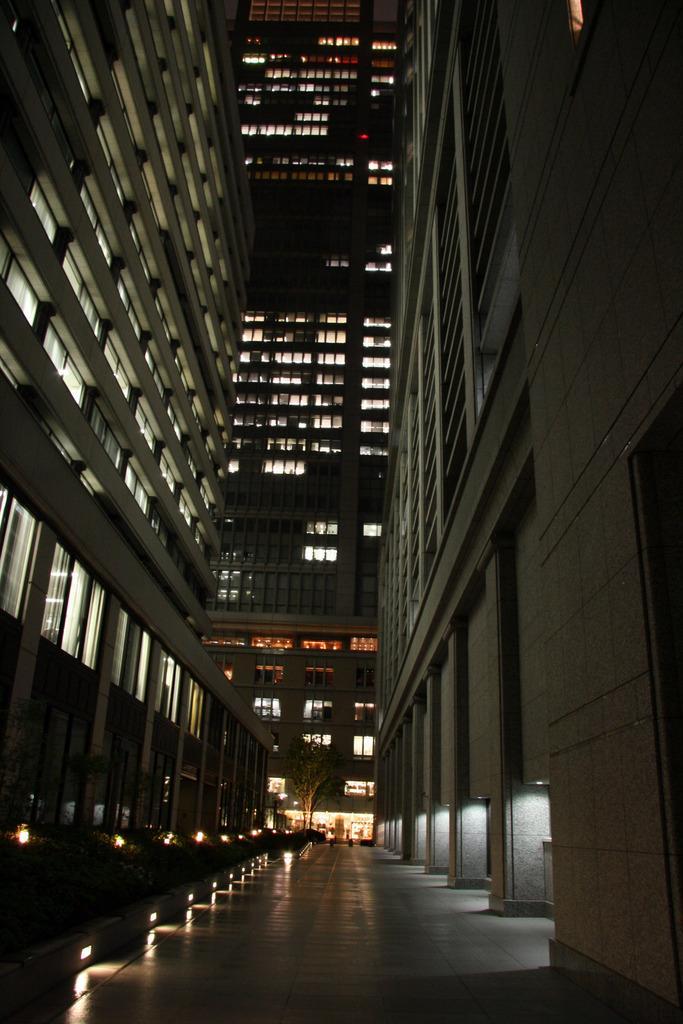How would you summarize this image in a sentence or two? In this picture we can see a path, buildings, windows, lights and tree. 